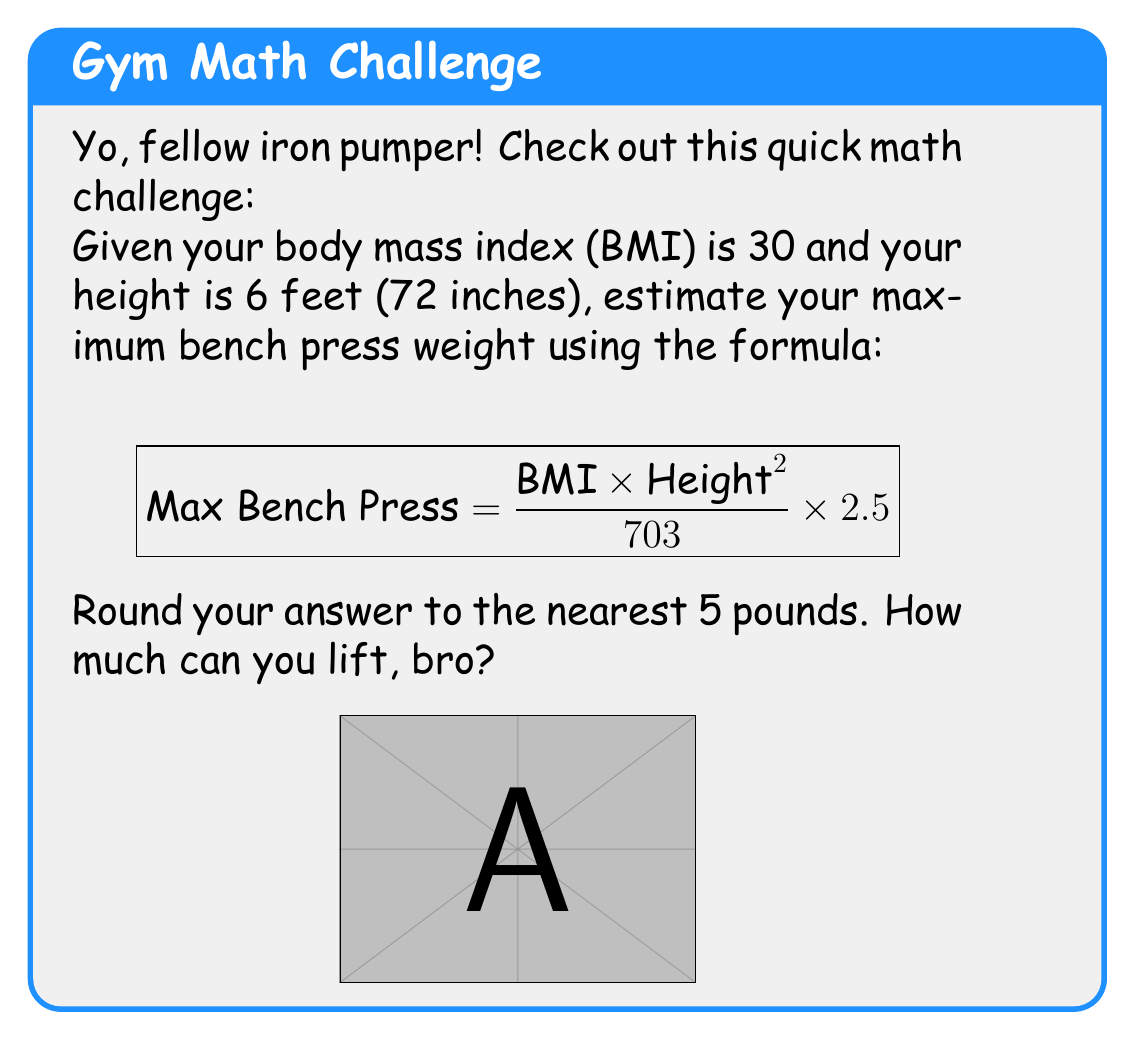What is the answer to this math problem? Alright, let's break this down step-by-step:

1) We're given:
   BMI = 30
   Height = 6 feet = 72 inches

2) Plug these into the formula:
   $$ \text{Max Bench Press} = \frac{30 \times 72^2}{703} \times 2.5 $$

3) Simplify the numerator:
   $$ \text{Max Bench Press} = \frac{30 \times 5184}{703} \times 2.5 $$
   $$ \text{Max Bench Press} = \frac{155520}{703} \times 2.5 $$

4) Divide:
   $$ \text{Max Bench Press} = 221.22 \times 2.5 $$

5) Multiply:
   $$ \text{Max Bench Press} = 553.05 $$

6) Round to the nearest 5 pounds:
   $$ \text{Max Bench Press} \approx 555 \text{ pounds} $$
Answer: 555 lbs 